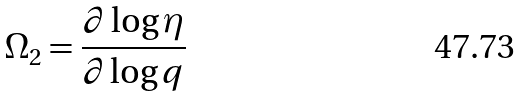<formula> <loc_0><loc_0><loc_500><loc_500>\Omega _ { 2 } = \frac { \partial \log \eta } { \partial \log q }</formula> 